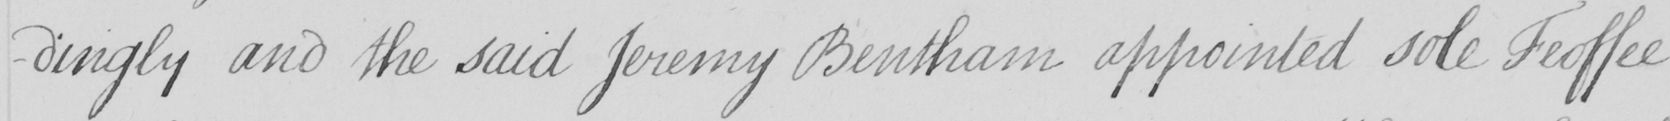Please provide the text content of this handwritten line. -dingly and the said Jeremy Bentham appointed sole Feoffee 